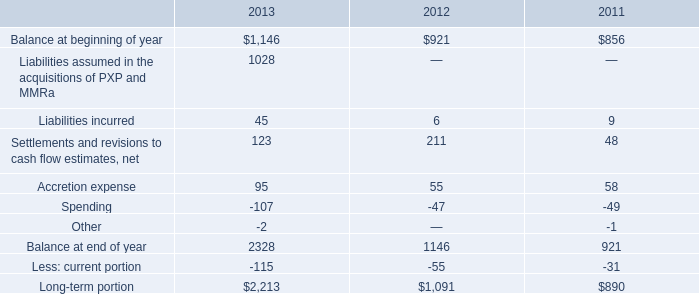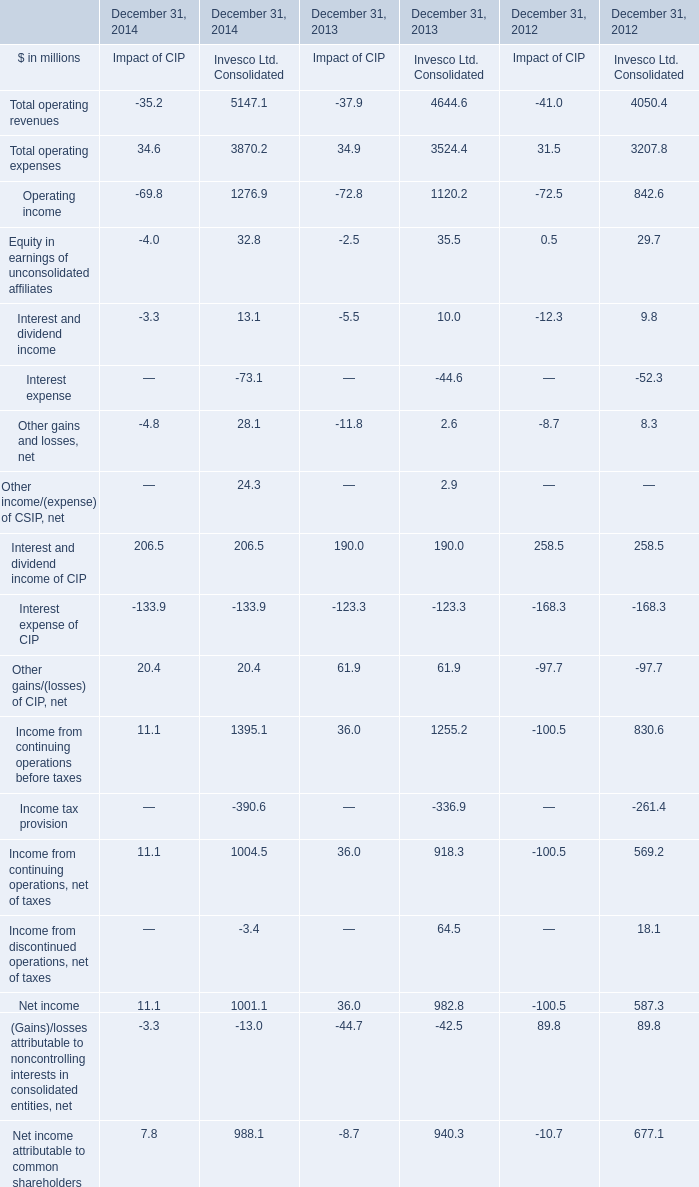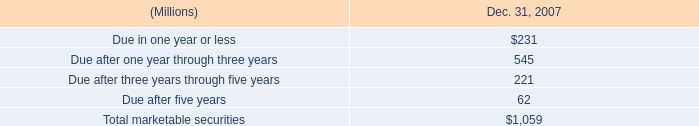For December 31, what year is Net income attributable to common shareholders in terms of Invesco Ltd. Consolidated the most? 
Answer: 2014. 